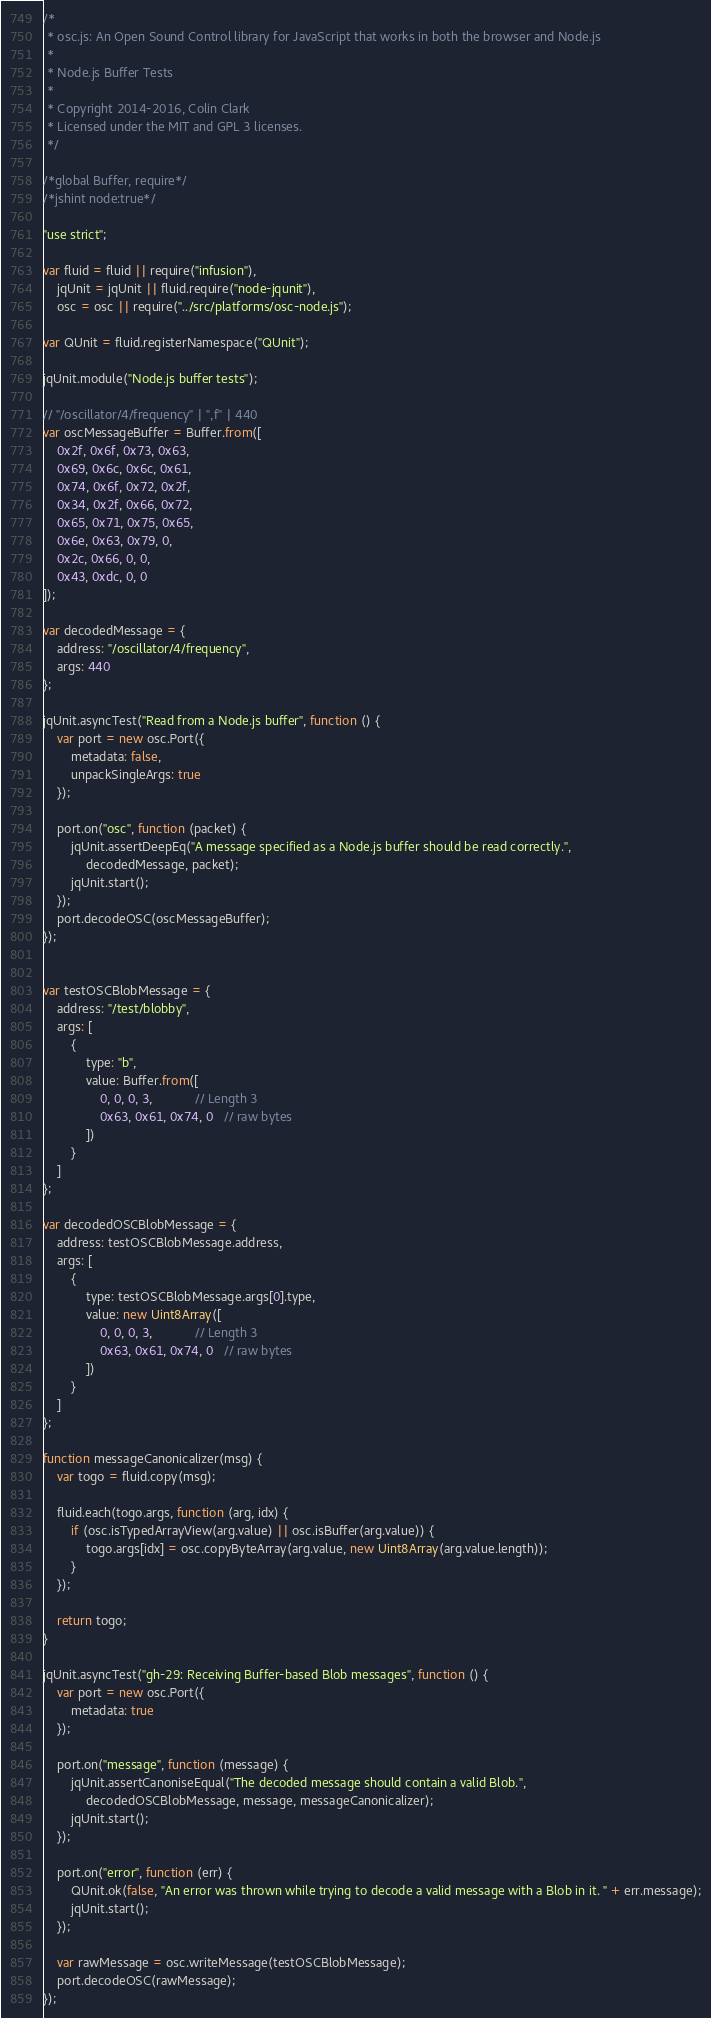Convert code to text. <code><loc_0><loc_0><loc_500><loc_500><_JavaScript_>/*
 * osc.js: An Open Sound Control library for JavaScript that works in both the browser and Node.js
 *
 * Node.js Buffer Tests
 *
 * Copyright 2014-2016, Colin Clark
 * Licensed under the MIT and GPL 3 licenses.
 */

/*global Buffer, require*/
/*jshint node:true*/

"use strict";

var fluid = fluid || require("infusion"),
    jqUnit = jqUnit || fluid.require("node-jqunit"),
    osc = osc || require("../src/platforms/osc-node.js");

var QUnit = fluid.registerNamespace("QUnit");

jqUnit.module("Node.js buffer tests");

// "/oscillator/4/frequency" | ",f" | 440
var oscMessageBuffer = Buffer.from([
    0x2f, 0x6f, 0x73, 0x63,
    0x69, 0x6c, 0x6c, 0x61,
    0x74, 0x6f, 0x72, 0x2f,
    0x34, 0x2f, 0x66, 0x72,
    0x65, 0x71, 0x75, 0x65,
    0x6e, 0x63, 0x79, 0,
    0x2c, 0x66, 0, 0,
    0x43, 0xdc, 0, 0
]);

var decodedMessage = {
    address: "/oscillator/4/frequency",
    args: 440
};

jqUnit.asyncTest("Read from a Node.js buffer", function () {
    var port = new osc.Port({
        metadata: false,
        unpackSingleArgs: true
    });

    port.on("osc", function (packet) {
        jqUnit.assertDeepEq("A message specified as a Node.js buffer should be read correctly.",
            decodedMessage, packet);
        jqUnit.start();
    });
    port.decodeOSC(oscMessageBuffer);
});


var testOSCBlobMessage = {
    address: "/test/blobby",
    args: [
        {
            type: "b",
            value: Buffer.from([
                0, 0, 0, 3,            // Length 3
                0x63, 0x61, 0x74, 0   // raw bytes
            ])
        }
    ]
};

var decodedOSCBlobMessage = {
    address: testOSCBlobMessage.address,
    args: [
        {
            type: testOSCBlobMessage.args[0].type,
            value: new Uint8Array([
                0, 0, 0, 3,            // Length 3
                0x63, 0x61, 0x74, 0   // raw bytes
            ])
        }
    ]
};

function messageCanonicalizer(msg) {
    var togo = fluid.copy(msg);

    fluid.each(togo.args, function (arg, idx) {
        if (osc.isTypedArrayView(arg.value) || osc.isBuffer(arg.value)) {
            togo.args[idx] = osc.copyByteArray(arg.value, new Uint8Array(arg.value.length));
        }
    });

    return togo;
}

jqUnit.asyncTest("gh-29: Receiving Buffer-based Blob messages", function () {
    var port = new osc.Port({
        metadata: true
    });

    port.on("message", function (message) {
        jqUnit.assertCanoniseEqual("The decoded message should contain a valid Blob.",
            decodedOSCBlobMessage, message, messageCanonicalizer);
        jqUnit.start();
    });

    port.on("error", function (err) {
        QUnit.ok(false, "An error was thrown while trying to decode a valid message with a Blob in it. " + err.message);
        jqUnit.start();
    });

    var rawMessage = osc.writeMessage(testOSCBlobMessage);
    port.decodeOSC(rawMessage);
});
</code> 